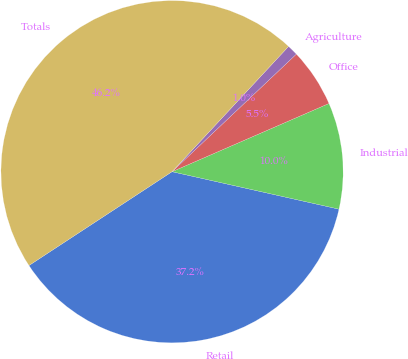<chart> <loc_0><loc_0><loc_500><loc_500><pie_chart><fcel>Retail<fcel>Industrial<fcel>Office<fcel>Agriculture<fcel>Totals<nl><fcel>37.25%<fcel>10.04%<fcel>5.53%<fcel>1.02%<fcel>46.16%<nl></chart> 